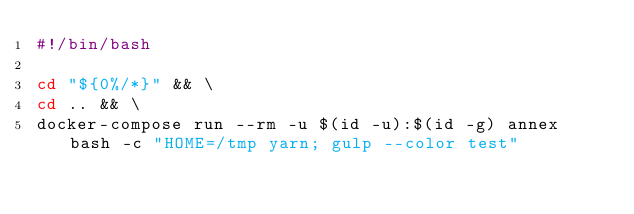Convert code to text. <code><loc_0><loc_0><loc_500><loc_500><_Bash_>#!/bin/bash

cd "${0%/*}" && \
cd .. && \
docker-compose run --rm -u $(id -u):$(id -g) annex bash -c "HOME=/tmp yarn; gulp --color test"
</code> 